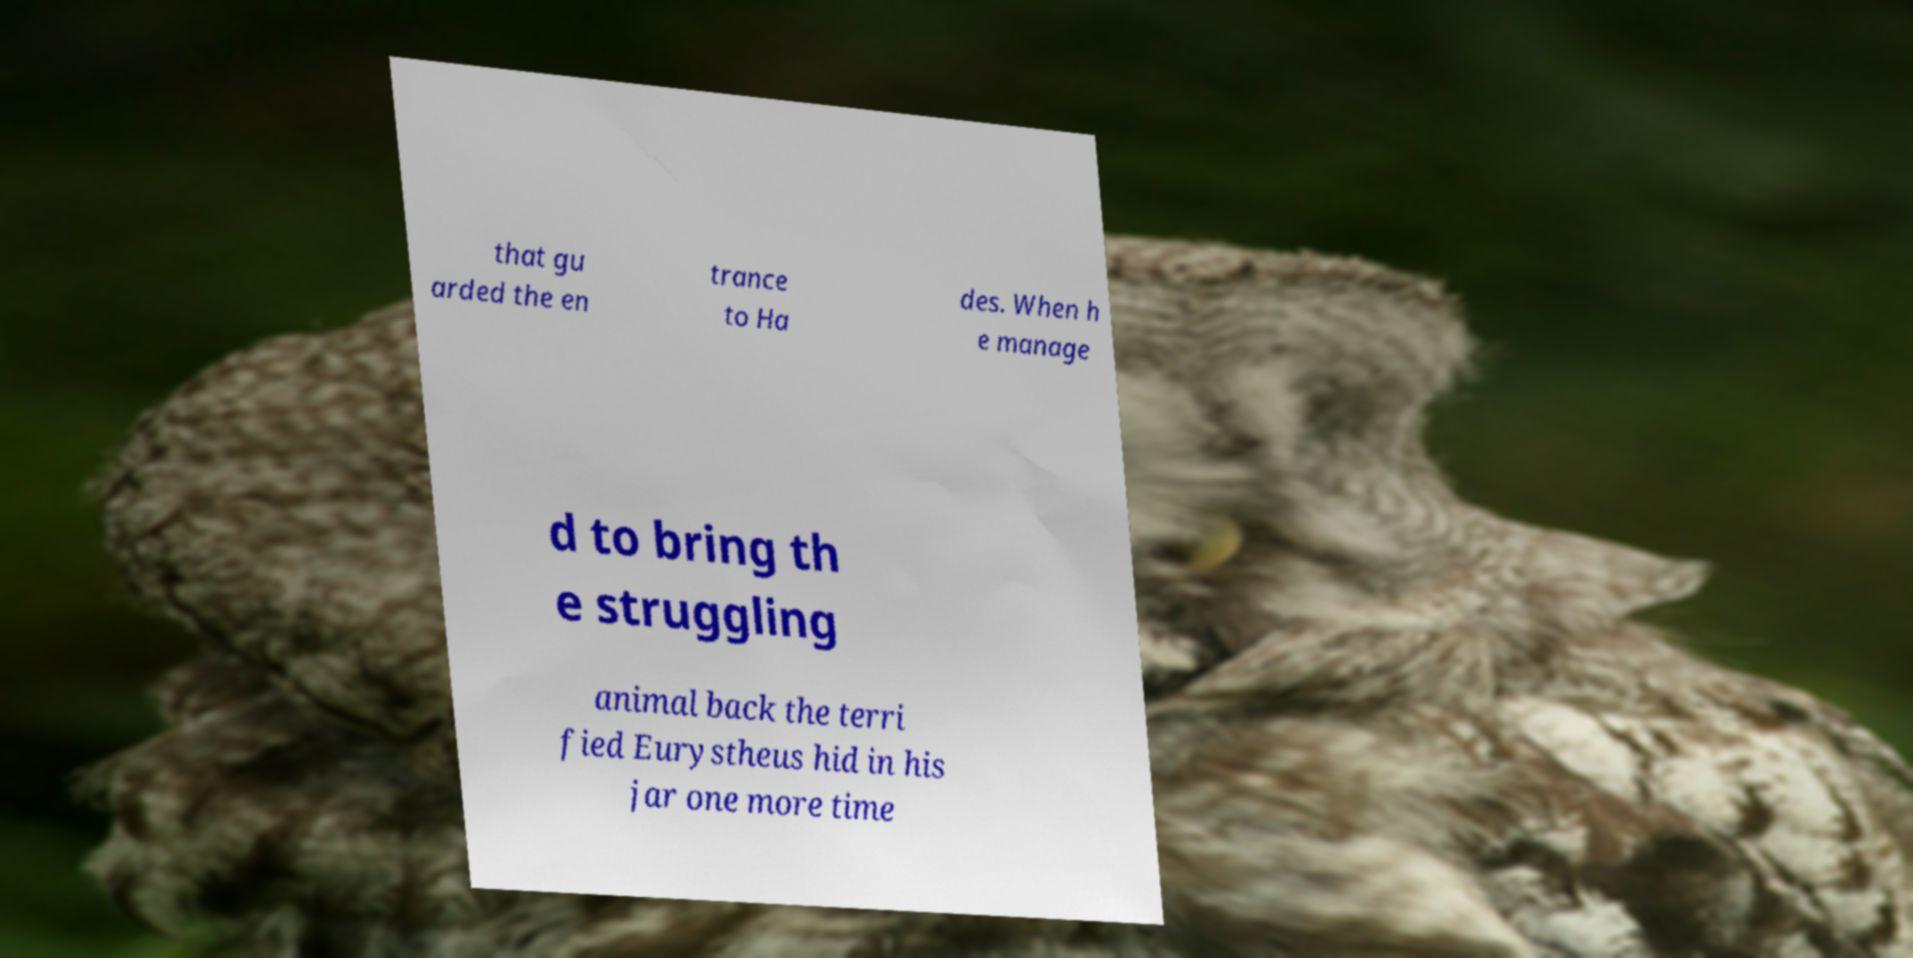There's text embedded in this image that I need extracted. Can you transcribe it verbatim? that gu arded the en trance to Ha des. When h e manage d to bring th e struggling animal back the terri fied Eurystheus hid in his jar one more time 